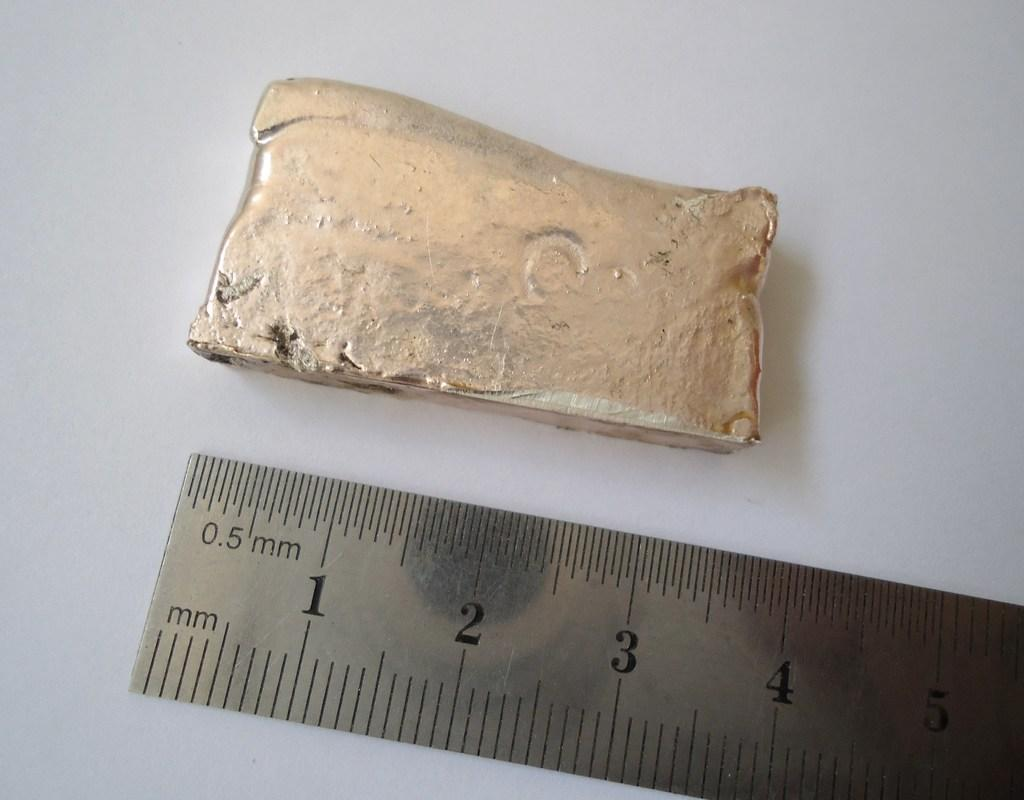What is one of the objects in the image? There is an iron piece in the image. What is the other object in the image? There is a scale in the image. Where are these objects located? Both objects are on a surface. How many jellyfish can be seen swimming near the iron piece in the image? There are no jellyfish present in the image; it only features an iron piece and a scale on a surface. 